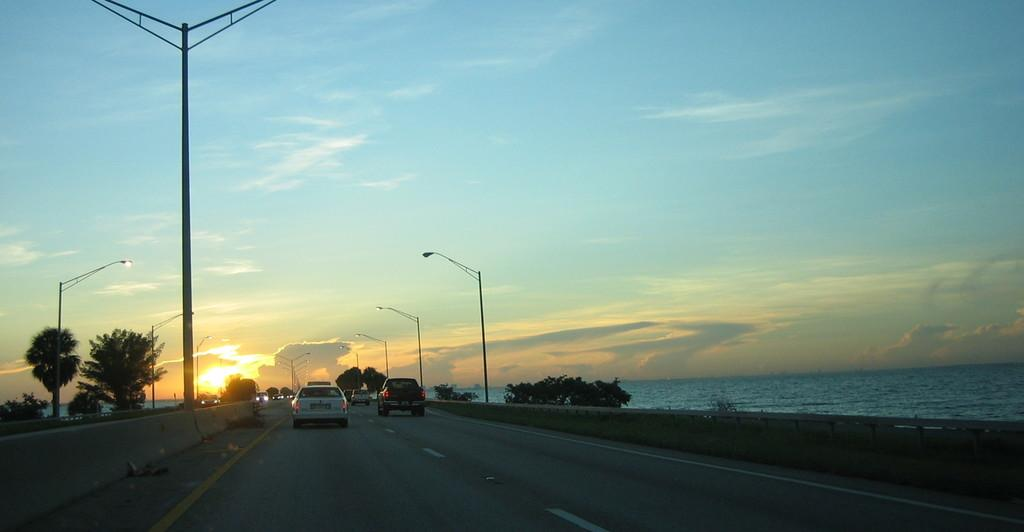What can be seen on the road in the image? There are vehicles on the road in the image. What type of vegetation is present on either side of the road? Trees are present on either side of the road. What type of lighting is visible in the image? Street lights are visible in the image. What is visible in the background of the image? Water and clouds are visible in the background of the image. What type of tools does the carpenter use in the image? There is no carpenter present in the image, so no tools can be observed. What is being rubbed against the surface of the road in the image? There is no rubbing action taking place in the image. What territory is being claimed by the vehicles in the image? The vehicles in the image are not claiming any territory; they are simply traveling on the road. 